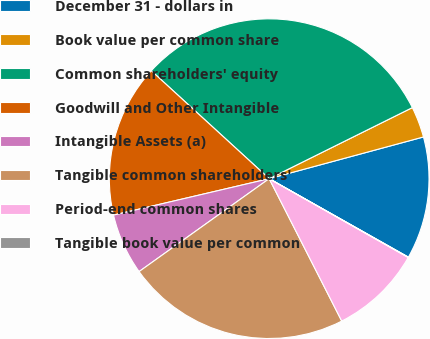Convert chart to OTSL. <chart><loc_0><loc_0><loc_500><loc_500><pie_chart><fcel>December 31 - dollars in<fcel>Book value per common share<fcel>Common shareholders' equity<fcel>Goodwill and Other Intangible<fcel>Intangible Assets (a)<fcel>Tangible common shareholders'<fcel>Period-end common shares<fcel>Tangible book value per common<nl><fcel>12.37%<fcel>3.13%<fcel>30.87%<fcel>15.46%<fcel>6.21%<fcel>22.63%<fcel>9.29%<fcel>0.04%<nl></chart> 